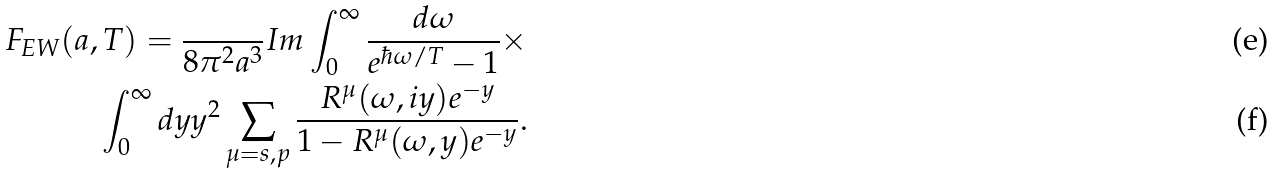<formula> <loc_0><loc_0><loc_500><loc_500>F _ { E W } ( a , T ) = \frac { } { 8 \pi ^ { 2 } a ^ { 3 } } I m \int _ { 0 } ^ { \infty } \frac { d \omega } { e ^ { \hbar { \omega } / T } - 1 } \times \\ \int _ { 0 } ^ { \infty } d y y ^ { 2 } \sum _ { \mu = s , p } \frac { R ^ { \mu } ( \omega , i y ) e ^ { - y } } { 1 - R ^ { \mu } ( \omega , y ) e ^ { - y } } .</formula> 